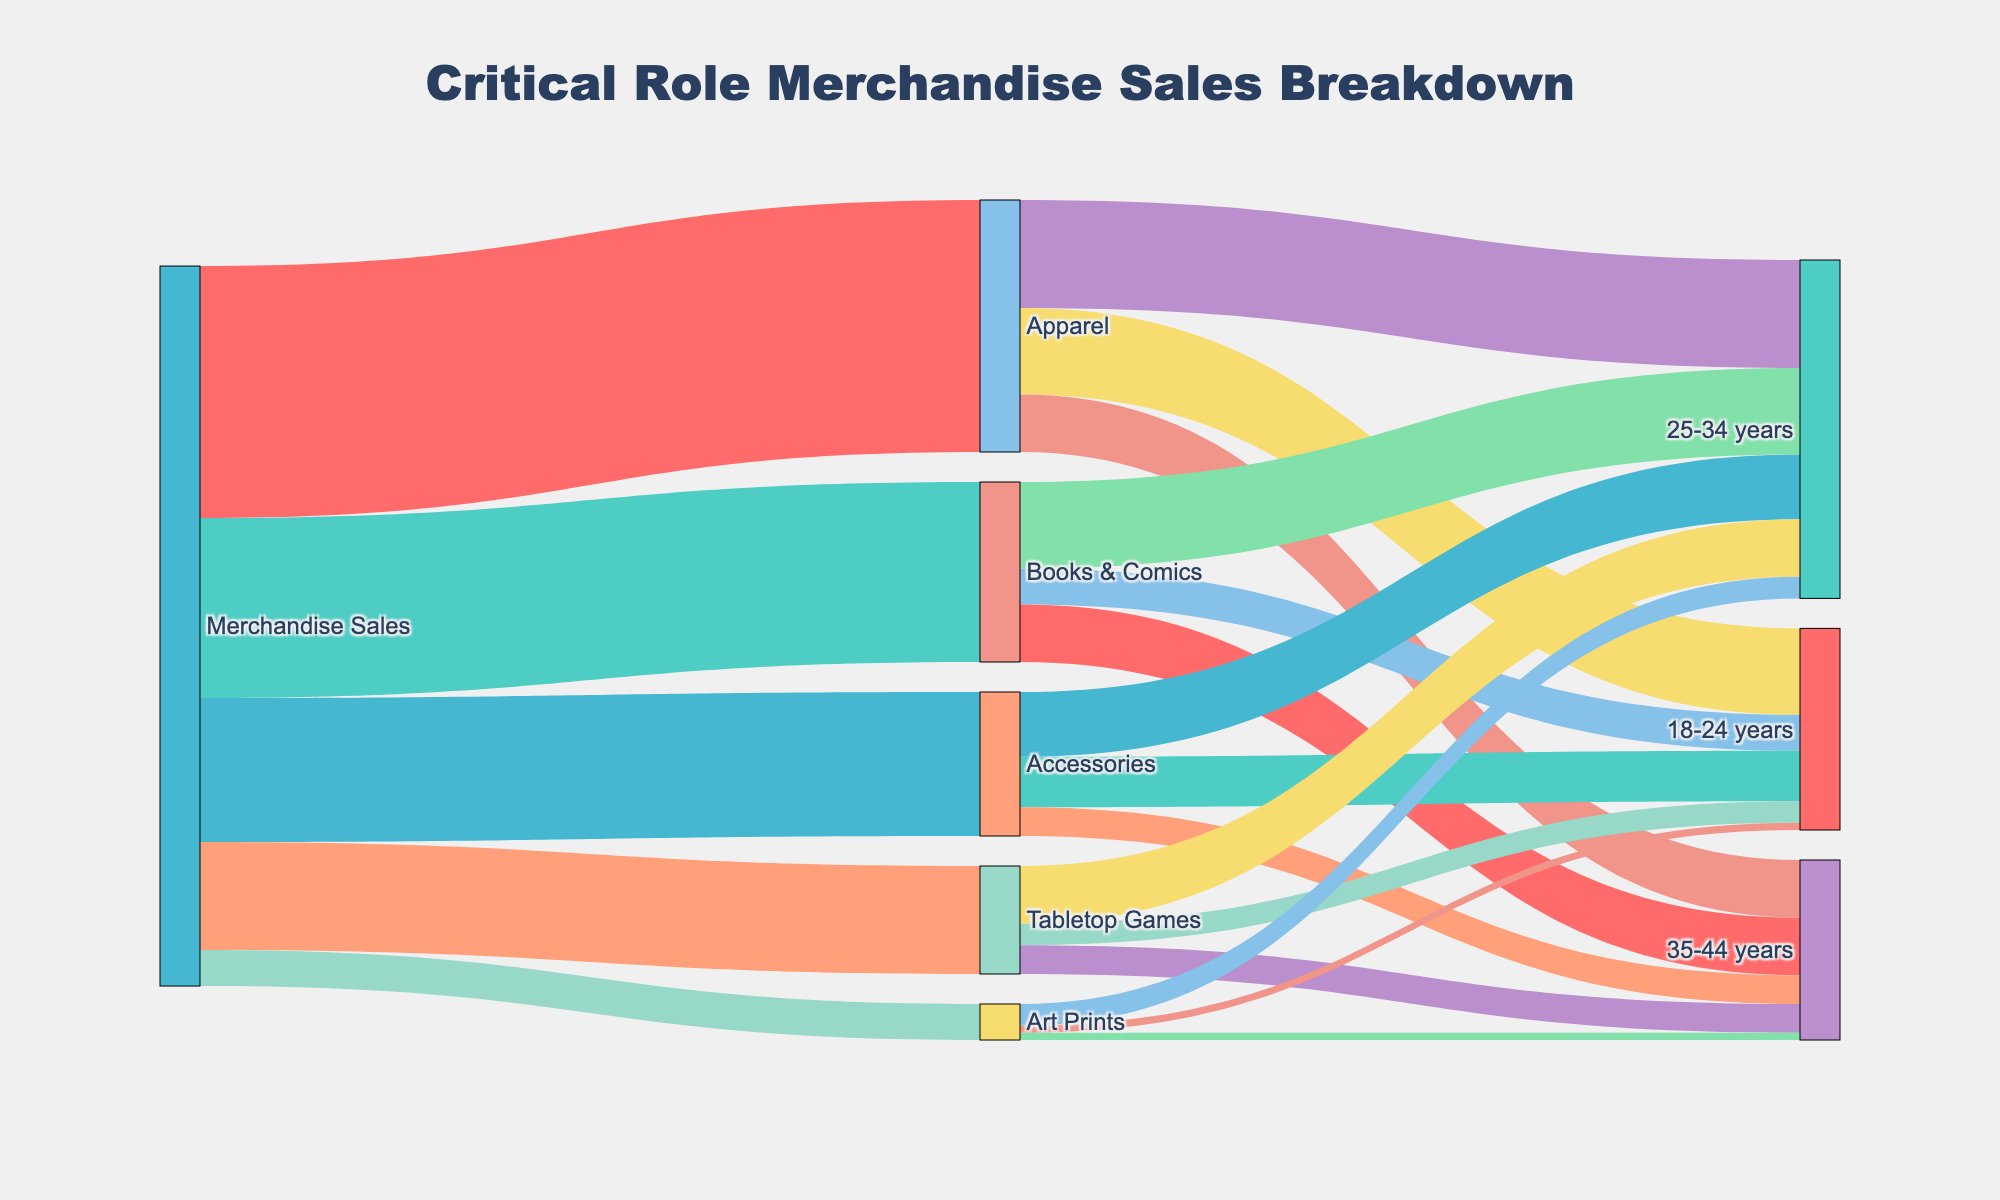what is the total sales of merchandise? The total sales can be found by summing the values of all product categories from the 'Merchandise Sales' source: 35000 (Apparel) + 25000 (Books & Comics) + 20000 (Accessories) + 15000 (Tabletop Games) + 5000 (Art Prints) = 100000
Answer: 100000 Which product category has the highest sales? From the diagram, we see that 'Apparel' receives the largest value from 'Merchandise Sales,' which is 35000. Therefore, 'Apparel' has the highest sales.
Answer: Apparel How much sales are made to 18-24 years and 25-34 years for Accessories combined? From the Accessories node, the sales to '18-24 years' is 7000 and to '25-34 years' is 9000. Summing these, 7000 + 9000 = 16000.
Answer: 16000 What is the average sales of Books & Comics among the three age groups? The sales of Books & Comics to the three age groups are 5000 (18-24 years), 12000 (25-34 years), and 8000 (35-44 years). The average is (5000 + 12000 + 8000) / 3 = 8333.33 (approximately).
Answer: 8333.33 Which age group has the least sales in the Art Prints category? For Art Prints, the sales to '18-24 years' is 1000, '25-34 years' is 3000, and '35-44 years' is 1000. The least sales are to both '18-24 years' and '35-44 years,' each with 1000.
Answer: 18-24 years and 35-44 years What is the difference in sales between Tabletop Games and Art Prints? The sales for Tabletop Games are 15000 and for Art Prints are 5000. The difference is 15000 - 5000 = 10000.
Answer: 10000 Which age group contributes most to the sales of Tabletop Games? From the diagram, the largest sales for Tabletop Games are to the 25-34 years age group, which is 8000.
Answer: 25-34 years What is the combined sales value of Apparel and Books & Comics for the 25-34 years age group? The sales of Apparel to 25-34 years is 15000 and Books & Comics to 25-34 years is 12000. The combined sales are 15000 + 12000 = 27000.
Answer: 27000 How many unique nodes are present in the diagram? The diagram consists of the unique nodes in both the source and target columns. Counting the unique labels: Merchandise Sales, Apparel, Books & Comics, Accessories, Tabletop Games, Art Prints, 18-24 years, 25-34 years, and 35-44 years, there are 9 unique nodes.
Answer: 9 